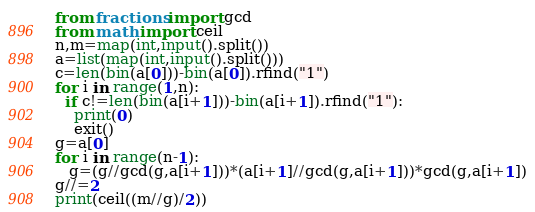Convert code to text. <code><loc_0><loc_0><loc_500><loc_500><_Python_>from fractions import gcd
from math import ceil
n,m=map(int,input().split())
a=list(map(int,input().split()))
c=len(bin(a[0]))-bin(a[0]).rfind("1")
for i in range(1,n):
  if c!=len(bin(a[i+1]))-bin(a[i+1]).rfind("1"):
    print(0)
    exit()
g=a[0]
for i in range(n-1):
   g=(g//gcd(g,a[i+1]))*(a[i+1]//gcd(g,a[i+1]))*gcd(g,a[i+1])
g//=2
print(ceil((m//g)/2))
</code> 